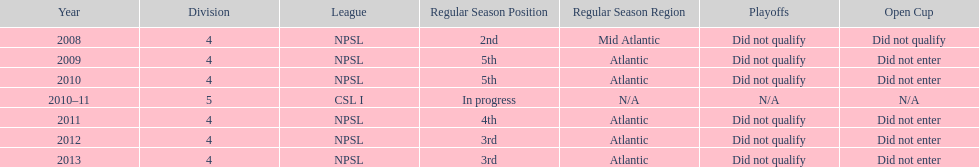How many 3rd place finishes has npsl had? 2. 